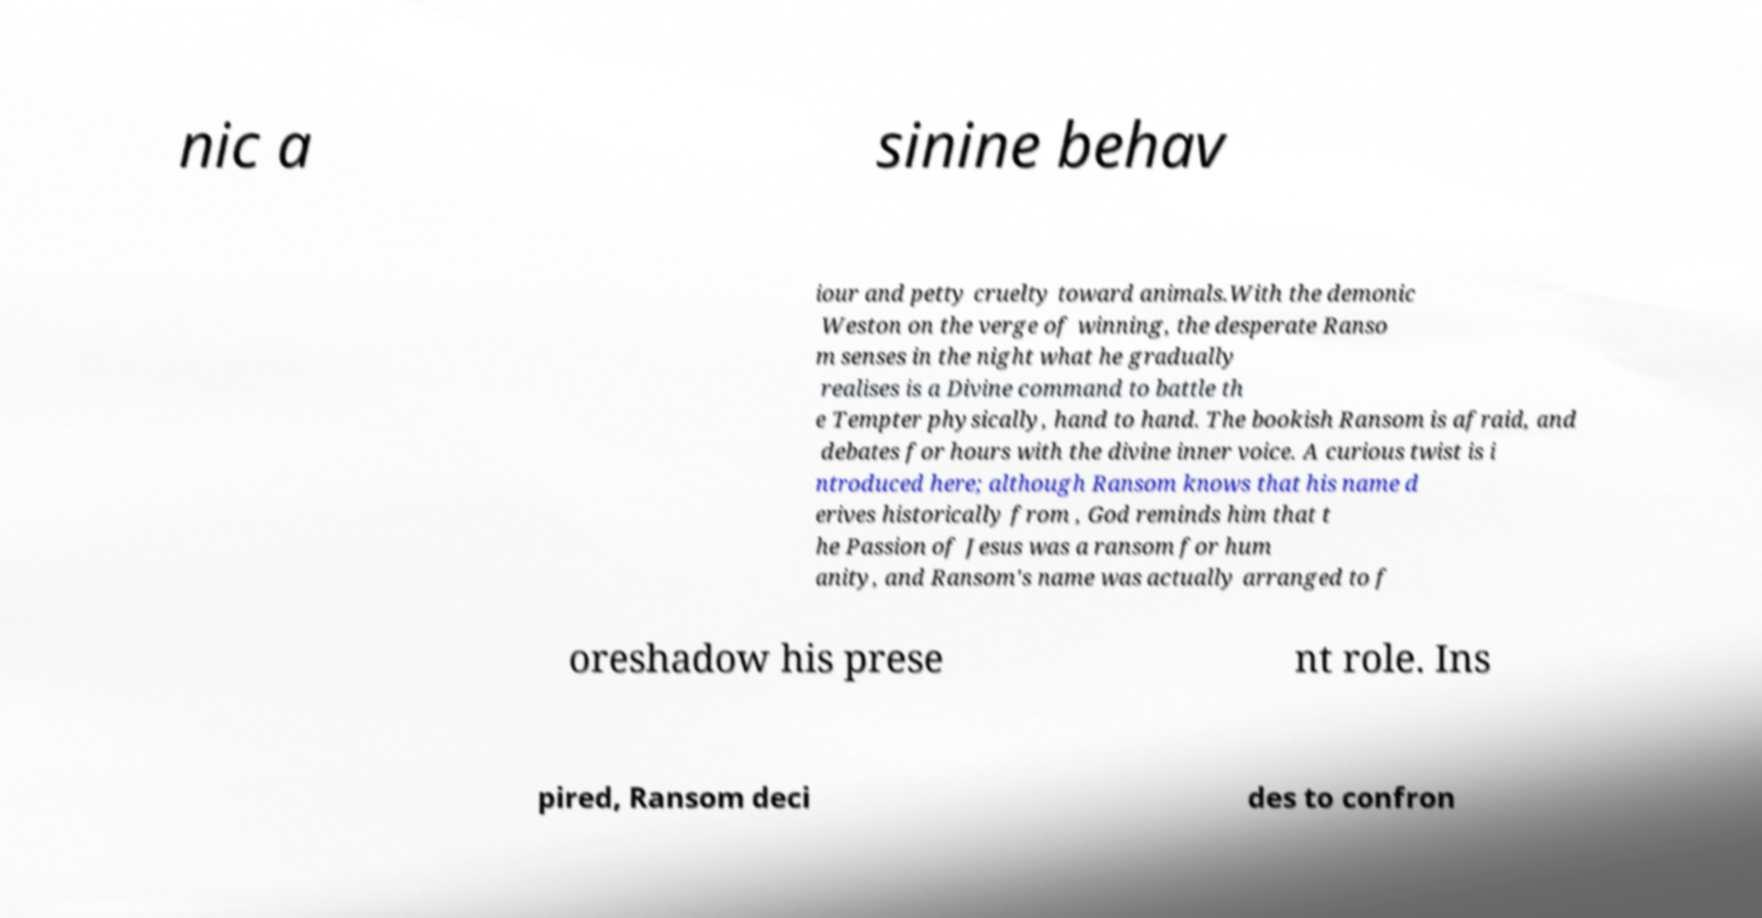Can you accurately transcribe the text from the provided image for me? nic a sinine behav iour and petty cruelty toward animals.With the demonic Weston on the verge of winning, the desperate Ranso m senses in the night what he gradually realises is a Divine command to battle th e Tempter physically, hand to hand. The bookish Ransom is afraid, and debates for hours with the divine inner voice. A curious twist is i ntroduced here; although Ransom knows that his name d erives historically from , God reminds him that t he Passion of Jesus was a ransom for hum anity, and Ransom's name was actually arranged to f oreshadow his prese nt role. Ins pired, Ransom deci des to confron 